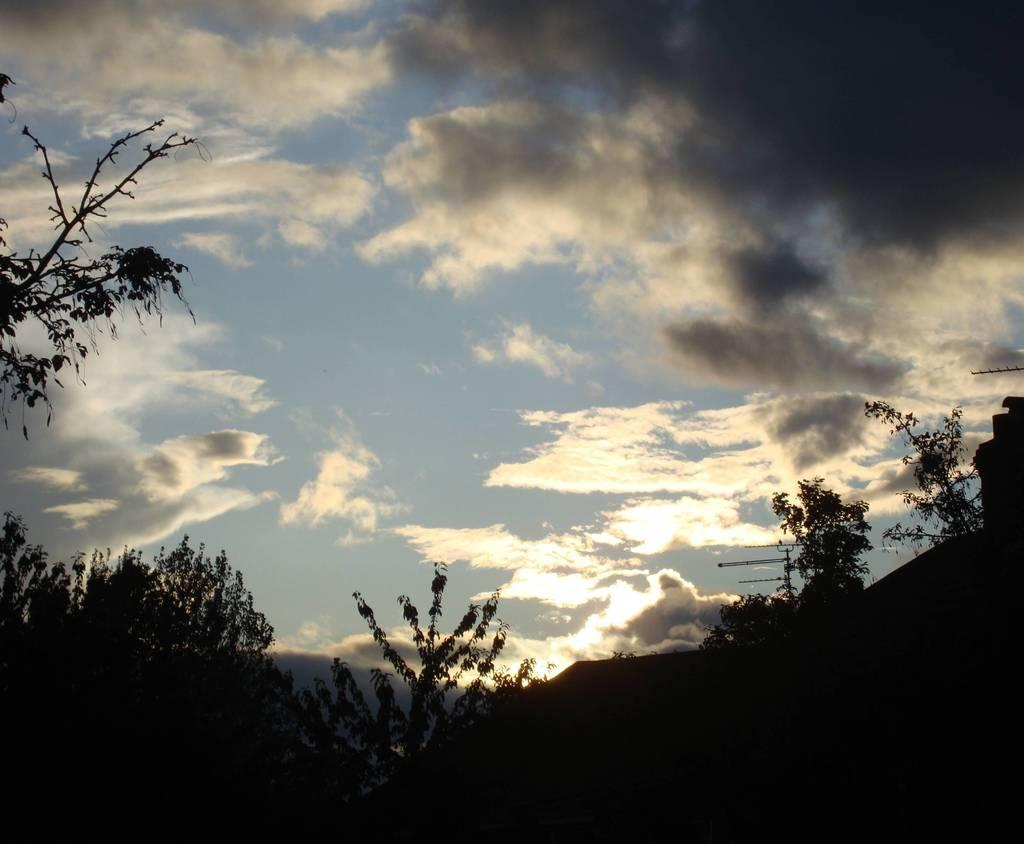What type of vegetation is present in the image? There is a group of trees in the image. What can be seen on the right side of the image? There are poles on the right side of the image. What is visible at the top of the image? The sky is visible at the top of the image. How would you describe the sky in the image? The sky appears to be cloudy. What language is being spoken by the trees in the image? Trees do not speak any language, so this question cannot be answered. What type of journey are the poles taking in the image? Poles do not take journeys, as they are stationary objects. 